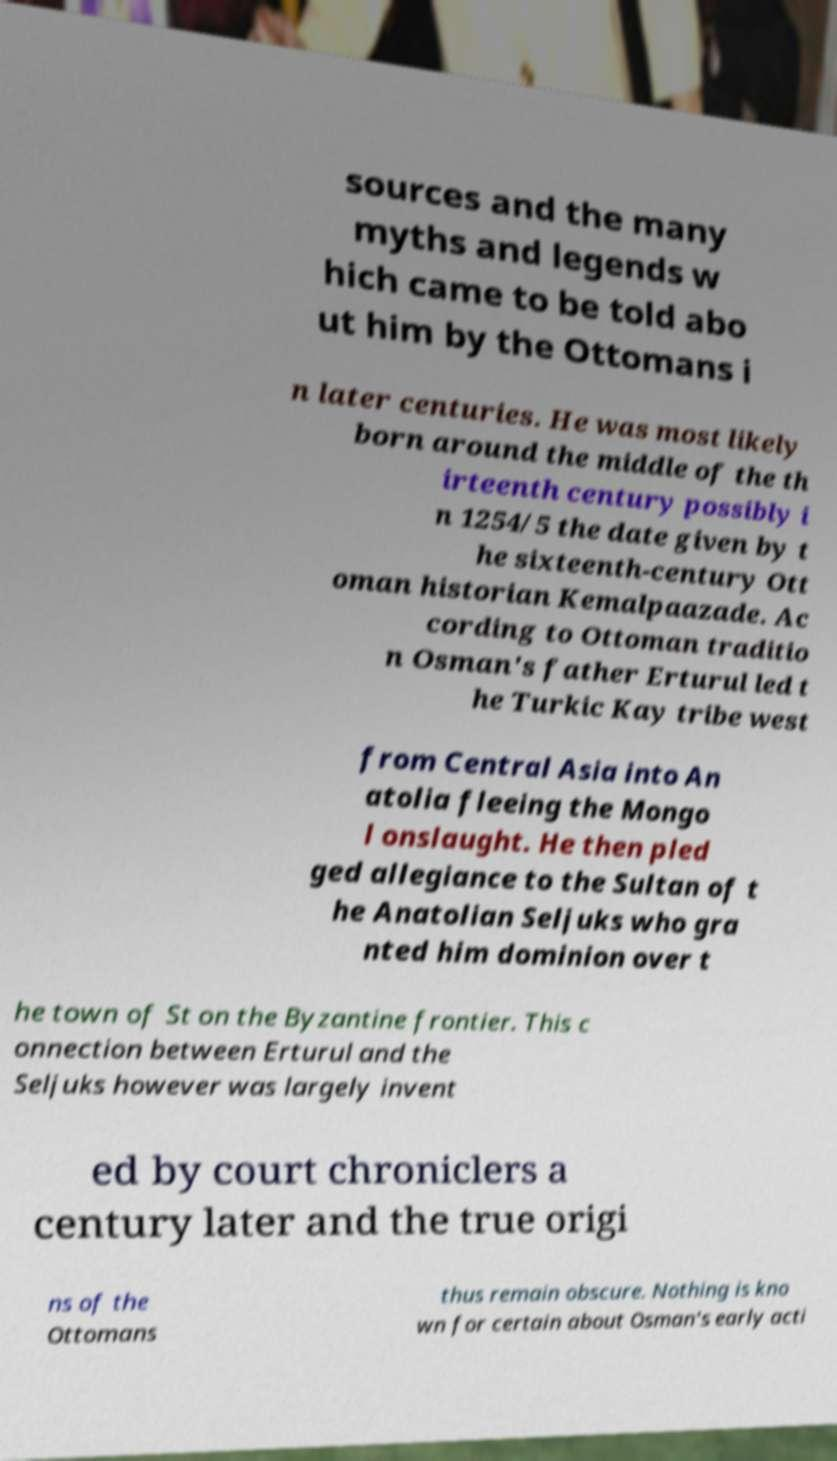I need the written content from this picture converted into text. Can you do that? sources and the many myths and legends w hich came to be told abo ut him by the Ottomans i n later centuries. He was most likely born around the middle of the th irteenth century possibly i n 1254/5 the date given by t he sixteenth-century Ott oman historian Kemalpaazade. Ac cording to Ottoman traditio n Osman's father Erturul led t he Turkic Kay tribe west from Central Asia into An atolia fleeing the Mongo l onslaught. He then pled ged allegiance to the Sultan of t he Anatolian Seljuks who gra nted him dominion over t he town of St on the Byzantine frontier. This c onnection between Erturul and the Seljuks however was largely invent ed by court chroniclers a century later and the true origi ns of the Ottomans thus remain obscure. Nothing is kno wn for certain about Osman's early acti 